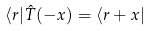Convert formula to latex. <formula><loc_0><loc_0><loc_500><loc_500>\langle r | \hat { T } ( - x ) = \langle r + x |</formula> 